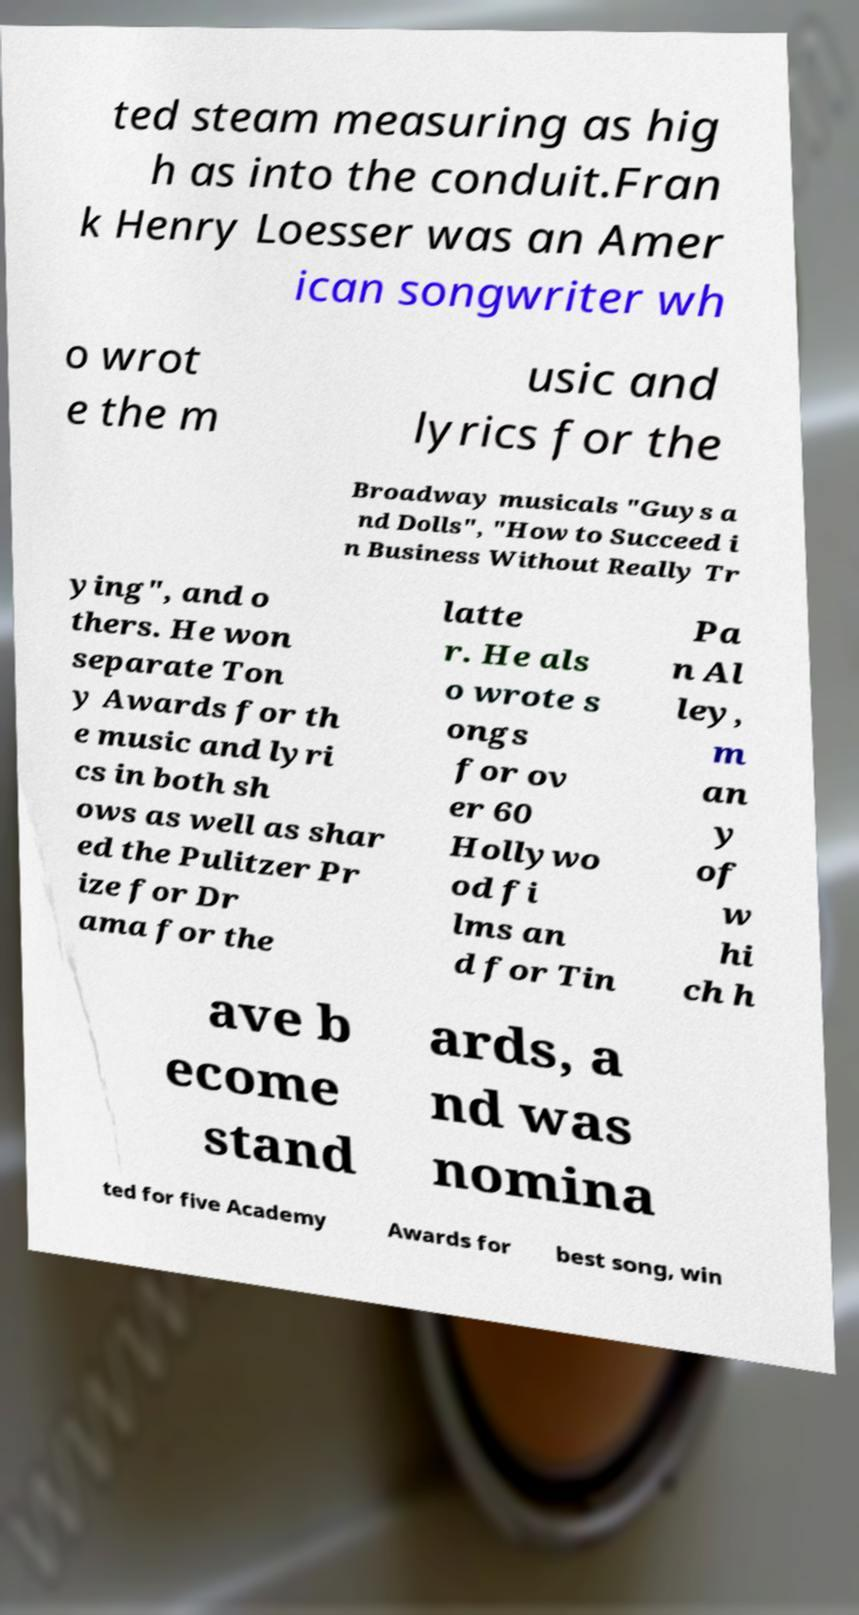There's text embedded in this image that I need extracted. Can you transcribe it verbatim? ted steam measuring as hig h as into the conduit.Fran k Henry Loesser was an Amer ican songwriter wh o wrot e the m usic and lyrics for the Broadway musicals "Guys a nd Dolls", "How to Succeed i n Business Without Really Tr ying", and o thers. He won separate Ton y Awards for th e music and lyri cs in both sh ows as well as shar ed the Pulitzer Pr ize for Dr ama for the latte r. He als o wrote s ongs for ov er 60 Hollywo od fi lms an d for Tin Pa n Al ley, m an y of w hi ch h ave b ecome stand ards, a nd was nomina ted for five Academy Awards for best song, win 